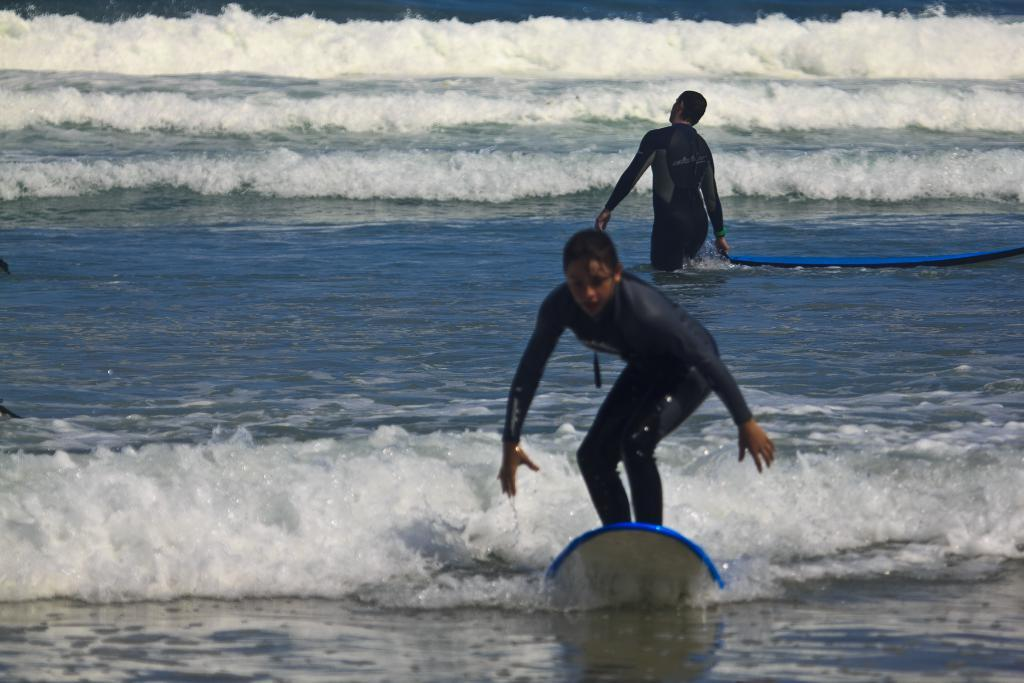What is the main subject of the image? There is a woman in the image. What is the woman doing in the image? The woman is surfing on water. Can you describe the person behind the woman? There is a person behind the woman, but their actions or appearance are not specified in the facts. What is located behind the person? There is a surf boat behind the person. What type of robin can be seen wearing a mitten in the image? There is no robin or mitten present in the image. How is the wax being used in the image? There is no wax present in the image. 